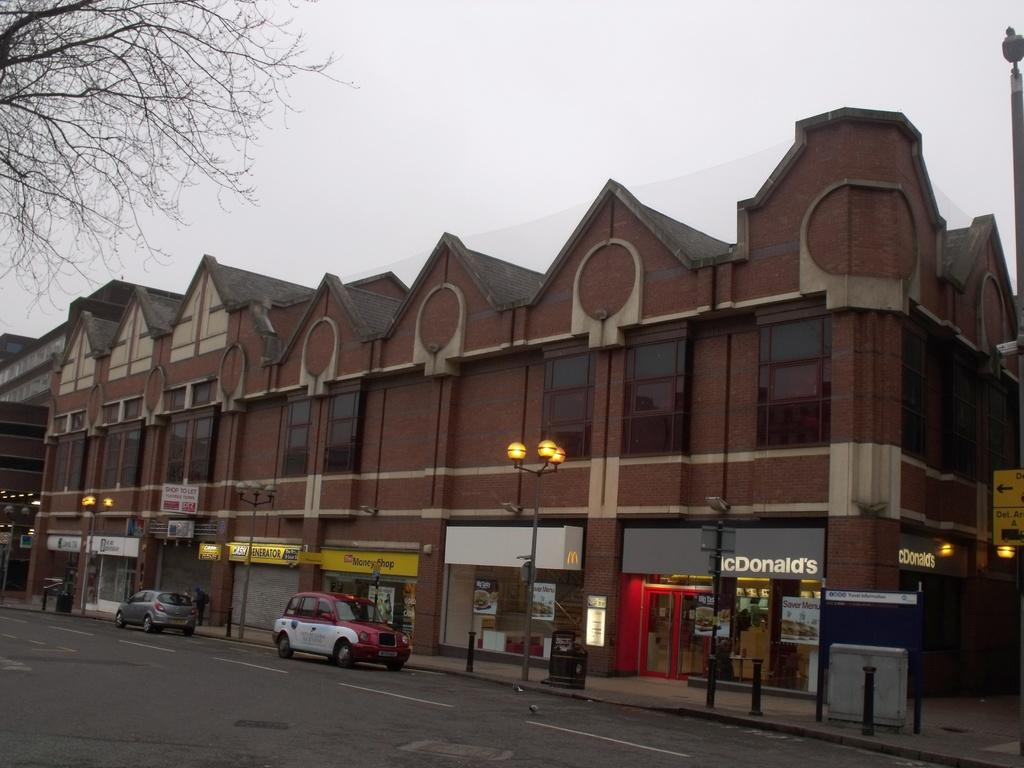<image>
Share a concise interpretation of the image provided. A McDonald's is located in the corner storefront of the building. 